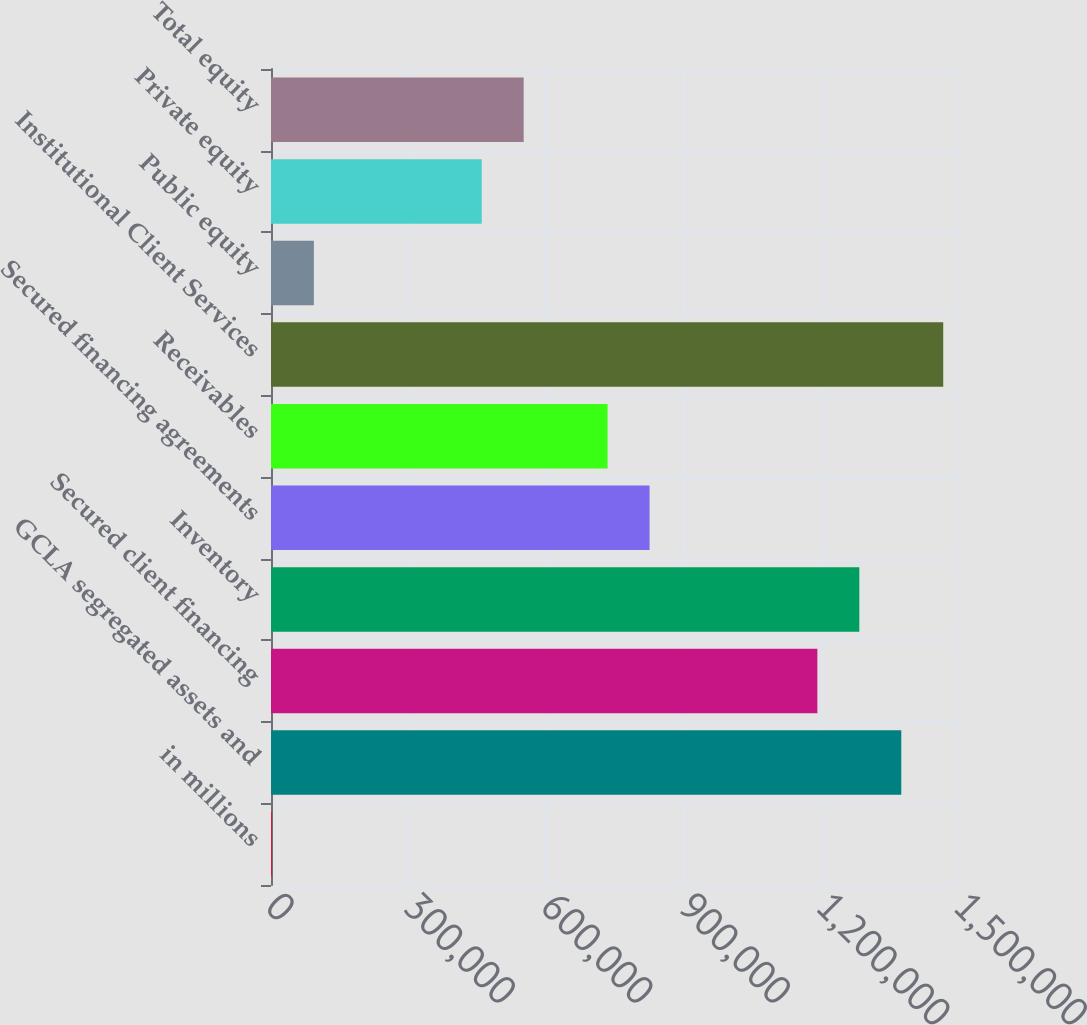Convert chart to OTSL. <chart><loc_0><loc_0><loc_500><loc_500><bar_chart><fcel>in millions<fcel>GCLA segregated assets and<fcel>Secured client financing<fcel>Inventory<fcel>Secured financing agreements<fcel>Receivables<fcel>Institutional Client Services<fcel>Public equity<fcel>Private equity<fcel>Total equity<nl><fcel>2017<fcel>1.37416e+06<fcel>1.1912e+06<fcel>1.28268e+06<fcel>825300<fcel>733824<fcel>1.46563e+06<fcel>93492.9<fcel>459396<fcel>550872<nl></chart> 